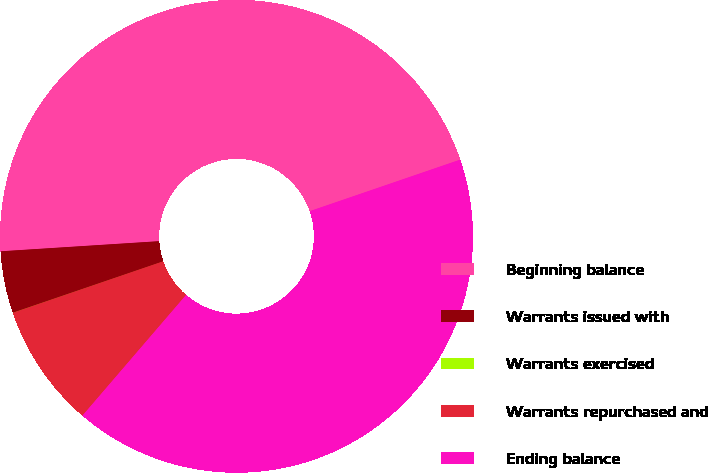Convert chart. <chart><loc_0><loc_0><loc_500><loc_500><pie_chart><fcel>Beginning balance<fcel>Warrants issued with<fcel>Warrants exercised<fcel>Warrants repurchased and<fcel>Ending balance<nl><fcel>45.76%<fcel>4.23%<fcel>0.01%<fcel>8.45%<fcel>41.54%<nl></chart> 